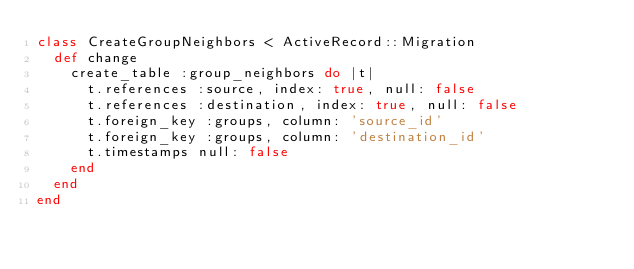<code> <loc_0><loc_0><loc_500><loc_500><_Ruby_>class CreateGroupNeighbors < ActiveRecord::Migration
  def change
    create_table :group_neighbors do |t|
      t.references :source, index: true, null: false
      t.references :destination, index: true, null: false
      t.foreign_key :groups, column: 'source_id'
      t.foreign_key :groups, column: 'destination_id'
      t.timestamps null: false
    end
  end
end
</code> 